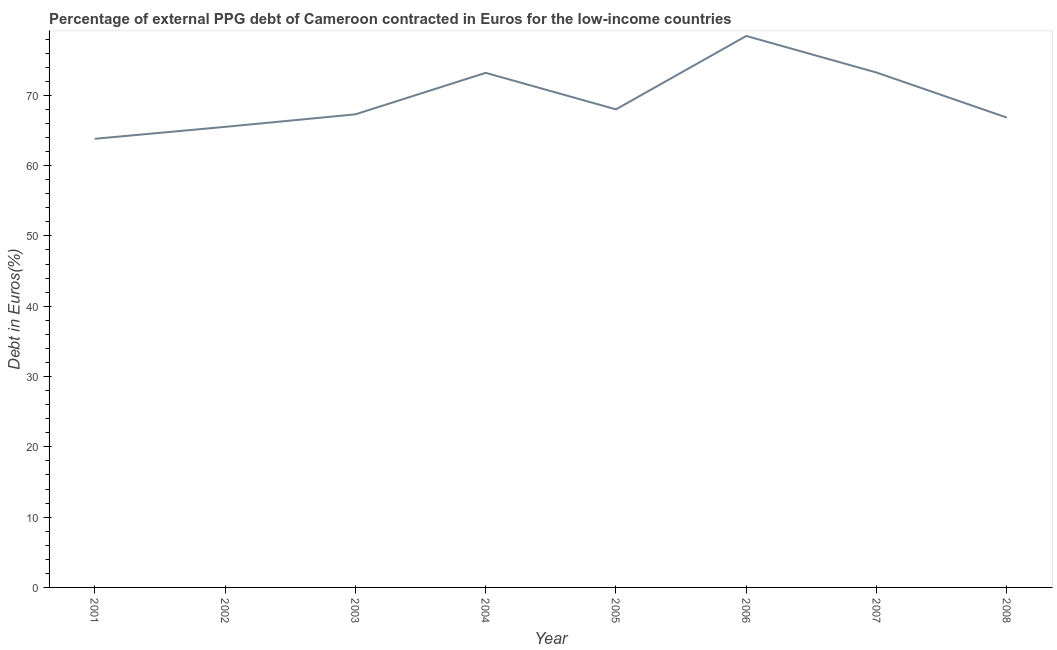What is the currency composition of ppg debt in 2004?
Make the answer very short. 73.2. Across all years, what is the maximum currency composition of ppg debt?
Provide a succinct answer. 78.44. Across all years, what is the minimum currency composition of ppg debt?
Your answer should be very brief. 63.81. In which year was the currency composition of ppg debt minimum?
Your answer should be very brief. 2001. What is the sum of the currency composition of ppg debt?
Keep it short and to the point. 556.31. What is the difference between the currency composition of ppg debt in 2001 and 2005?
Provide a short and direct response. -4.19. What is the average currency composition of ppg debt per year?
Your response must be concise. 69.54. What is the median currency composition of ppg debt?
Your response must be concise. 67.65. In how many years, is the currency composition of ppg debt greater than 46 %?
Ensure brevity in your answer.  8. Do a majority of the years between 2007 and 2008 (inclusive) have currency composition of ppg debt greater than 26 %?
Keep it short and to the point. Yes. What is the ratio of the currency composition of ppg debt in 2004 to that in 2006?
Offer a terse response. 0.93. Is the difference between the currency composition of ppg debt in 2004 and 2007 greater than the difference between any two years?
Make the answer very short. No. What is the difference between the highest and the second highest currency composition of ppg debt?
Your answer should be compact. 5.21. Is the sum of the currency composition of ppg debt in 2006 and 2007 greater than the maximum currency composition of ppg debt across all years?
Provide a succinct answer. Yes. What is the difference between the highest and the lowest currency composition of ppg debt?
Offer a very short reply. 14.63. Does the currency composition of ppg debt monotonically increase over the years?
Give a very brief answer. No. What is the difference between two consecutive major ticks on the Y-axis?
Your response must be concise. 10. Does the graph contain grids?
Your answer should be compact. No. What is the title of the graph?
Provide a succinct answer. Percentage of external PPG debt of Cameroon contracted in Euros for the low-income countries. What is the label or title of the Y-axis?
Ensure brevity in your answer.  Debt in Euros(%). What is the Debt in Euros(%) of 2001?
Provide a short and direct response. 63.81. What is the Debt in Euros(%) of 2002?
Ensure brevity in your answer.  65.51. What is the Debt in Euros(%) of 2003?
Give a very brief answer. 67.29. What is the Debt in Euros(%) in 2004?
Provide a succinct answer. 73.2. What is the Debt in Euros(%) of 2005?
Keep it short and to the point. 68. What is the Debt in Euros(%) in 2006?
Make the answer very short. 78.44. What is the Debt in Euros(%) in 2007?
Offer a terse response. 73.23. What is the Debt in Euros(%) of 2008?
Your answer should be very brief. 66.83. What is the difference between the Debt in Euros(%) in 2001 and 2002?
Your response must be concise. -1.7. What is the difference between the Debt in Euros(%) in 2001 and 2003?
Keep it short and to the point. -3.48. What is the difference between the Debt in Euros(%) in 2001 and 2004?
Offer a very short reply. -9.38. What is the difference between the Debt in Euros(%) in 2001 and 2005?
Offer a terse response. -4.19. What is the difference between the Debt in Euros(%) in 2001 and 2006?
Ensure brevity in your answer.  -14.63. What is the difference between the Debt in Euros(%) in 2001 and 2007?
Your response must be concise. -9.42. What is the difference between the Debt in Euros(%) in 2001 and 2008?
Your response must be concise. -3.01. What is the difference between the Debt in Euros(%) in 2002 and 2003?
Ensure brevity in your answer.  -1.78. What is the difference between the Debt in Euros(%) in 2002 and 2004?
Offer a very short reply. -7.68. What is the difference between the Debt in Euros(%) in 2002 and 2005?
Offer a very short reply. -2.49. What is the difference between the Debt in Euros(%) in 2002 and 2006?
Make the answer very short. -12.93. What is the difference between the Debt in Euros(%) in 2002 and 2007?
Keep it short and to the point. -7.72. What is the difference between the Debt in Euros(%) in 2002 and 2008?
Your answer should be very brief. -1.32. What is the difference between the Debt in Euros(%) in 2003 and 2004?
Offer a terse response. -5.9. What is the difference between the Debt in Euros(%) in 2003 and 2005?
Your answer should be very brief. -0.71. What is the difference between the Debt in Euros(%) in 2003 and 2006?
Make the answer very short. -11.15. What is the difference between the Debt in Euros(%) in 2003 and 2007?
Offer a terse response. -5.94. What is the difference between the Debt in Euros(%) in 2003 and 2008?
Keep it short and to the point. 0.46. What is the difference between the Debt in Euros(%) in 2004 and 2005?
Provide a short and direct response. 5.19. What is the difference between the Debt in Euros(%) in 2004 and 2006?
Make the answer very short. -5.24. What is the difference between the Debt in Euros(%) in 2004 and 2007?
Make the answer very short. -0.04. What is the difference between the Debt in Euros(%) in 2004 and 2008?
Your answer should be very brief. 6.37. What is the difference between the Debt in Euros(%) in 2005 and 2006?
Your response must be concise. -10.44. What is the difference between the Debt in Euros(%) in 2005 and 2007?
Your answer should be compact. -5.23. What is the difference between the Debt in Euros(%) in 2005 and 2008?
Make the answer very short. 1.17. What is the difference between the Debt in Euros(%) in 2006 and 2007?
Your response must be concise. 5.21. What is the difference between the Debt in Euros(%) in 2006 and 2008?
Provide a short and direct response. 11.61. What is the difference between the Debt in Euros(%) in 2007 and 2008?
Give a very brief answer. 6.41. What is the ratio of the Debt in Euros(%) in 2001 to that in 2002?
Your answer should be very brief. 0.97. What is the ratio of the Debt in Euros(%) in 2001 to that in 2003?
Give a very brief answer. 0.95. What is the ratio of the Debt in Euros(%) in 2001 to that in 2004?
Provide a short and direct response. 0.87. What is the ratio of the Debt in Euros(%) in 2001 to that in 2005?
Offer a terse response. 0.94. What is the ratio of the Debt in Euros(%) in 2001 to that in 2006?
Make the answer very short. 0.81. What is the ratio of the Debt in Euros(%) in 2001 to that in 2007?
Offer a very short reply. 0.87. What is the ratio of the Debt in Euros(%) in 2001 to that in 2008?
Offer a very short reply. 0.95. What is the ratio of the Debt in Euros(%) in 2002 to that in 2003?
Provide a short and direct response. 0.97. What is the ratio of the Debt in Euros(%) in 2002 to that in 2004?
Keep it short and to the point. 0.9. What is the ratio of the Debt in Euros(%) in 2002 to that in 2005?
Provide a short and direct response. 0.96. What is the ratio of the Debt in Euros(%) in 2002 to that in 2006?
Your response must be concise. 0.83. What is the ratio of the Debt in Euros(%) in 2002 to that in 2007?
Provide a short and direct response. 0.9. What is the ratio of the Debt in Euros(%) in 2002 to that in 2008?
Keep it short and to the point. 0.98. What is the ratio of the Debt in Euros(%) in 2003 to that in 2004?
Make the answer very short. 0.92. What is the ratio of the Debt in Euros(%) in 2003 to that in 2006?
Give a very brief answer. 0.86. What is the ratio of the Debt in Euros(%) in 2003 to that in 2007?
Your response must be concise. 0.92. What is the ratio of the Debt in Euros(%) in 2004 to that in 2005?
Provide a short and direct response. 1.08. What is the ratio of the Debt in Euros(%) in 2004 to that in 2006?
Your answer should be compact. 0.93. What is the ratio of the Debt in Euros(%) in 2004 to that in 2008?
Offer a terse response. 1.09. What is the ratio of the Debt in Euros(%) in 2005 to that in 2006?
Give a very brief answer. 0.87. What is the ratio of the Debt in Euros(%) in 2005 to that in 2007?
Offer a terse response. 0.93. What is the ratio of the Debt in Euros(%) in 2006 to that in 2007?
Provide a short and direct response. 1.07. What is the ratio of the Debt in Euros(%) in 2006 to that in 2008?
Your response must be concise. 1.17. What is the ratio of the Debt in Euros(%) in 2007 to that in 2008?
Offer a terse response. 1.1. 